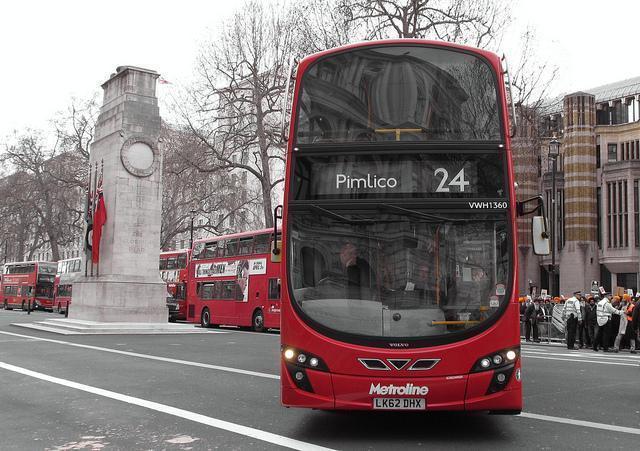Which bus company owns this bus?
Make your selection and explain in format: 'Answer: answer
Rationale: rationale.'
Options: Metroline, pimlico, vwh, volvo. Answer: metroline.
Rationale: The front of the bus says metroline. 